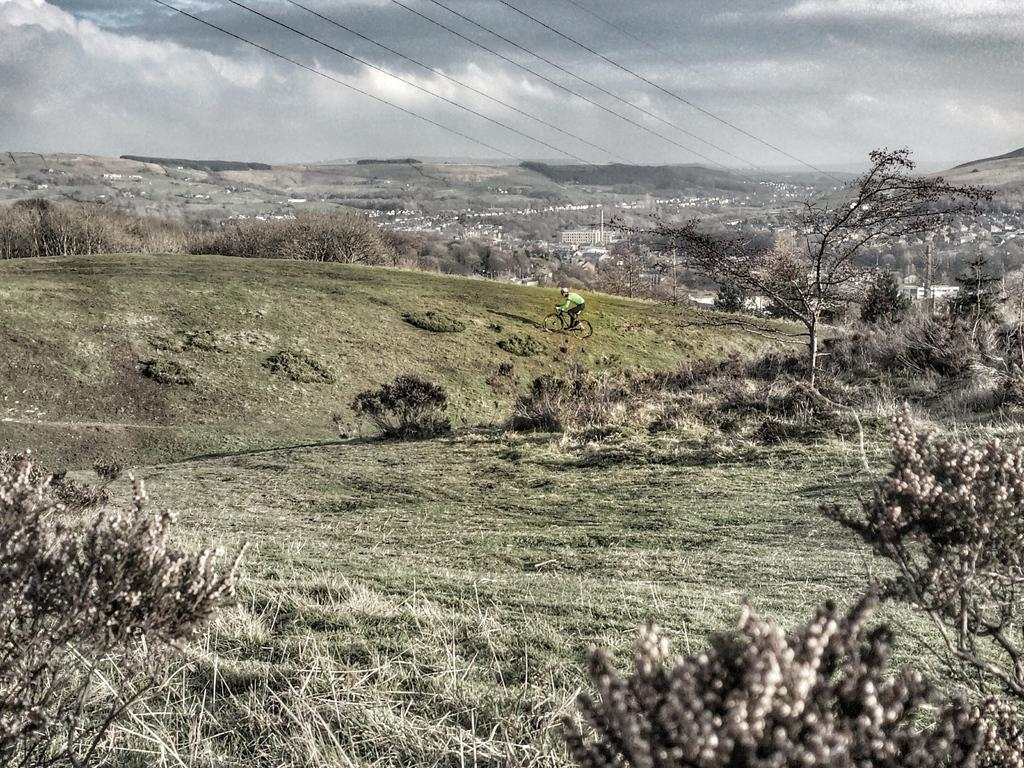What is the person in the image doing? There is a person riding a bike in the image. How would you describe the weather in the image? The sky is cloudy in the image. What type of vegetation can be seen in the image? There are many trees in the image. What is the terrain like in the image? There is a grassy land in the image. Can you see a knife being used by the person riding the bike in the image? There is no knife present in the image, and the person riding the bike is not using any tools or utensils. 